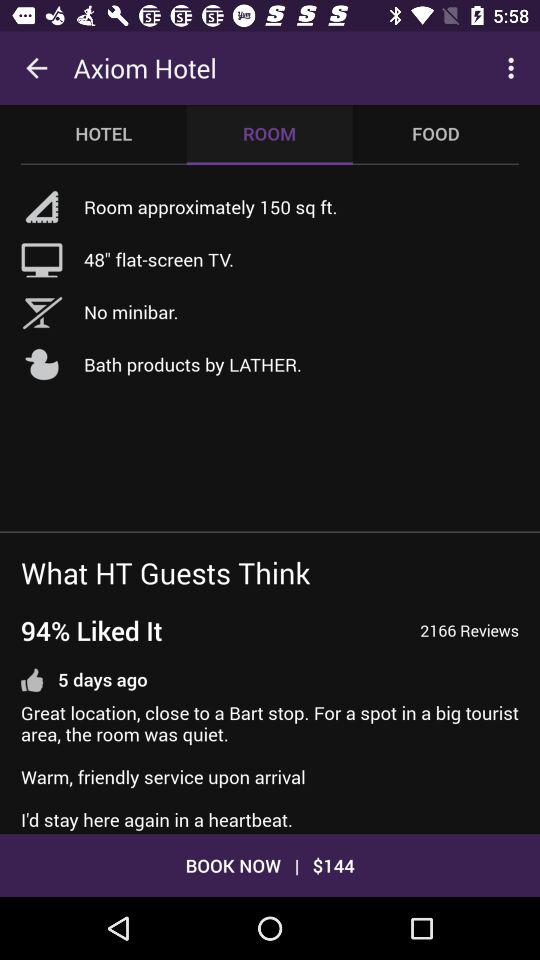How many hotel reviews are there? There are 2166 reviews. 